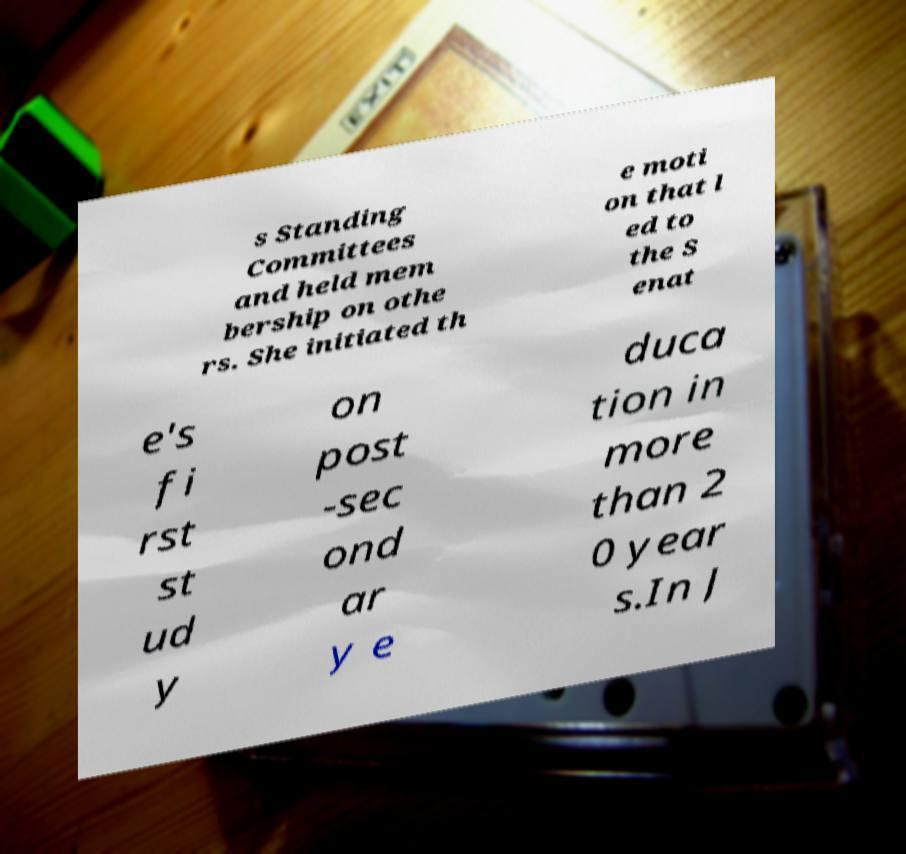I need the written content from this picture converted into text. Can you do that? s Standing Committees and held mem bership on othe rs. She initiated th e moti on that l ed to the S enat e's fi rst st ud y on post -sec ond ar y e duca tion in more than 2 0 year s.In J 